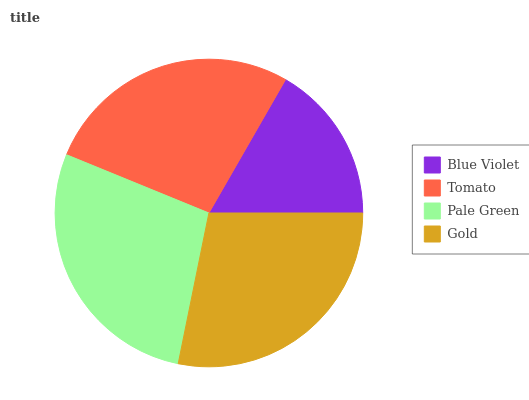Is Blue Violet the minimum?
Answer yes or no. Yes. Is Gold the maximum?
Answer yes or no. Yes. Is Tomato the minimum?
Answer yes or no. No. Is Tomato the maximum?
Answer yes or no. No. Is Tomato greater than Blue Violet?
Answer yes or no. Yes. Is Blue Violet less than Tomato?
Answer yes or no. Yes. Is Blue Violet greater than Tomato?
Answer yes or no. No. Is Tomato less than Blue Violet?
Answer yes or no. No. Is Pale Green the high median?
Answer yes or no. Yes. Is Tomato the low median?
Answer yes or no. Yes. Is Gold the high median?
Answer yes or no. No. Is Pale Green the low median?
Answer yes or no. No. 